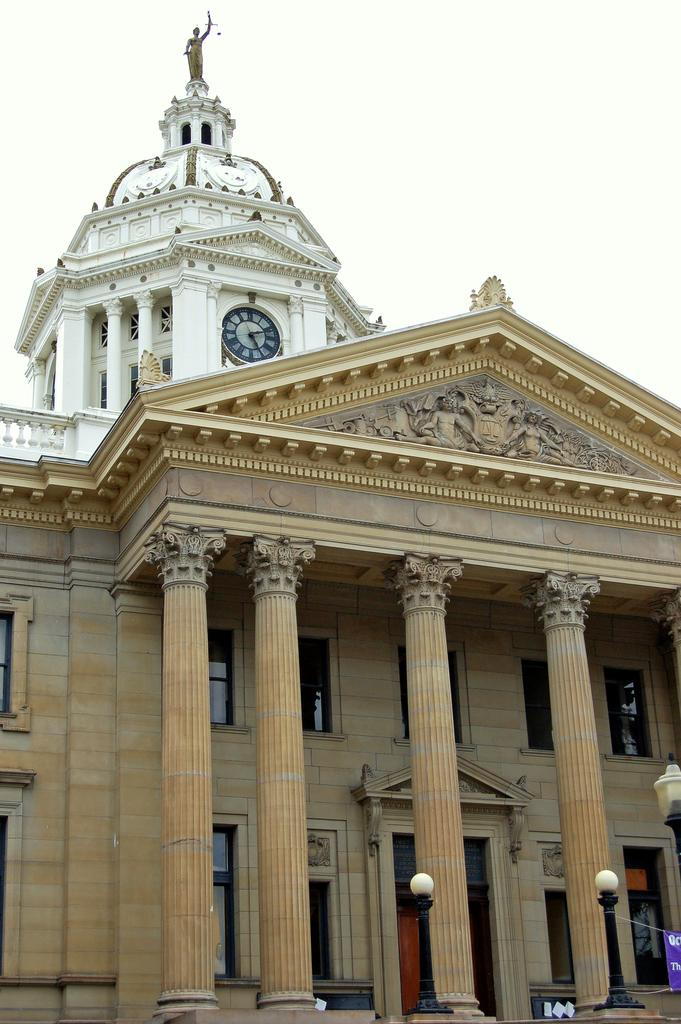What is the main subject in the center of the image? There is a building in the center of the image. What can be seen in the background of the image? The sky is visible in the background of the image. What type of structures are present at the bottom of the image? There are light poles at the bottom of the image. What type of wine is being thought about by the thing in the image? There is no wine, thought, or thing present in the image. 